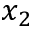<formula> <loc_0><loc_0><loc_500><loc_500>x _ { 2 }</formula> 